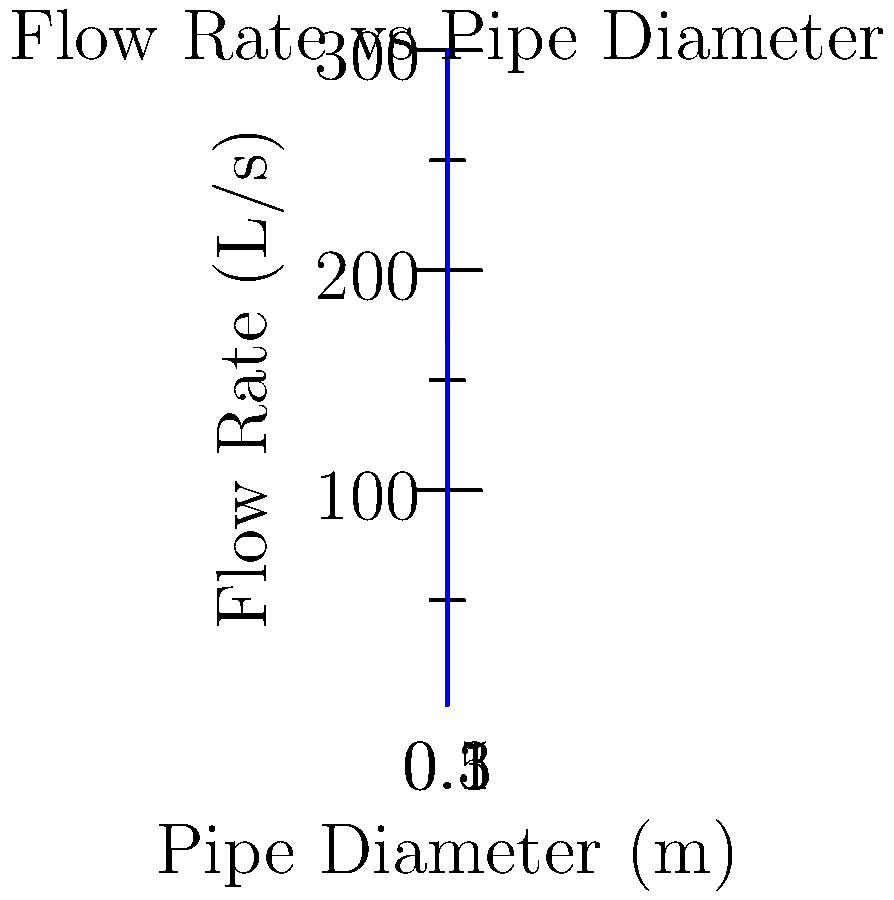In a city's water supply system, the relationship between pipe diameter and flow rate is crucial for efficient distribution. Based on the graph, which shows flow rates for different pipe diameters, what is the approximate increase in flow rate when upgrading from a 0.2m diameter pipe to a 0.4m diameter pipe? How might this information influence decisions in pharmaceutical manufacturing facilities that require precise water flow control? To solve this problem, we'll follow these steps:

1. Identify the flow rates for 0.2m and 0.4m diameter pipes from the graph:
   - For 0.2m diameter: Flow rate ≈ 19.2 L/s
   - For 0.4m diameter: Flow rate ≈ 153.6 L/s

2. Calculate the difference in flow rates:
   $\Delta \text{Flow Rate} = 153.6 \text{ L/s} - 19.2 \text{ L/s} = 134.4 \text{ L/s}$

3. The increase in flow rate is approximately 134.4 L/s.

This information is crucial for pharmaceutical manufacturing facilities because:

a) Precise water flow control is essential for maintaining consistent drug quality and production rates.

b) Upgrading pipe diameters can significantly increase water supply capacity, potentially allowing for expansion of production facilities or implementation of new processes that require higher water flow rates.

c) The non-linear relationship between pipe diameter and flow rate (as evident from the graph) demonstrates that small increases in pipe diameter can lead to large increases in flow capacity, which could be cost-effective for facility upgrades.

d) Understanding this relationship helps in optimizing water distribution systems within pharmaceutical plants, ensuring adequate supply for critical processes such as cleaning, cooling, and ingredient mixing.

e) It allows for better planning of water-dependent processes in drug development and manufacturing, potentially reducing bottlenecks and improving overall efficiency.
Answer: 134.4 L/s increase 